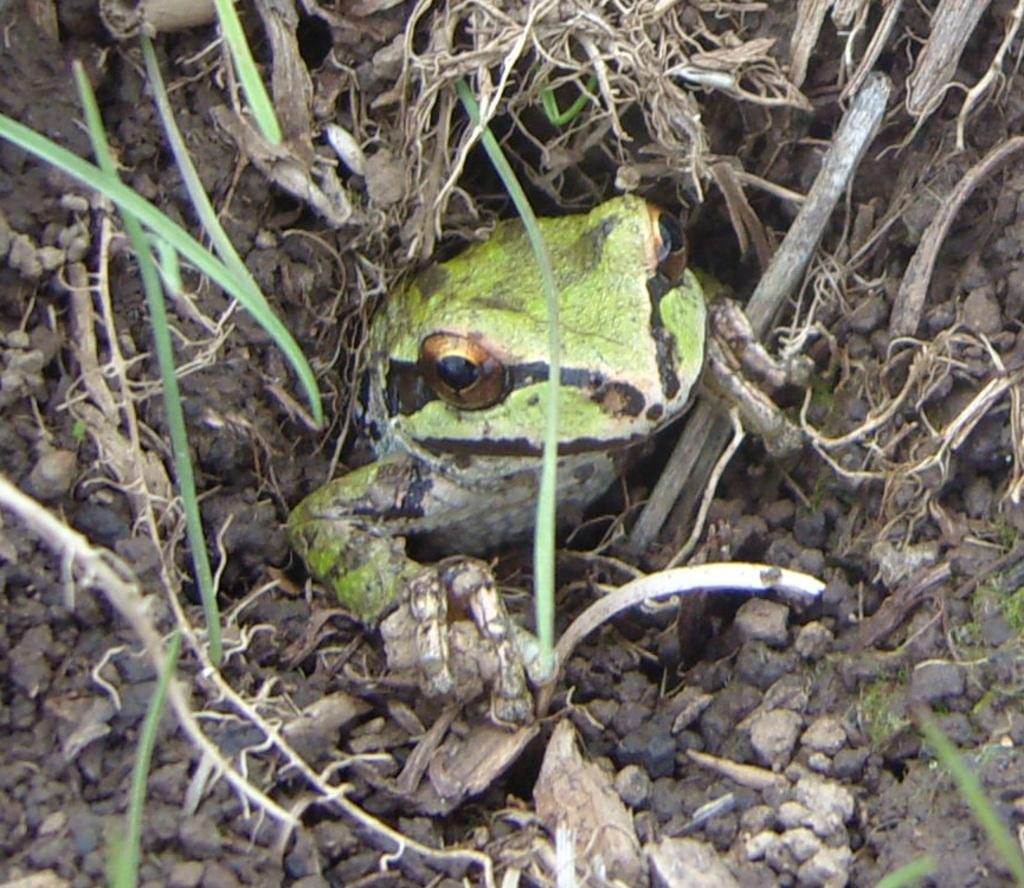What type of surface is visible in the image? There is a mud surface in the image. What feature can be seen on the mud surface? There is a hole in the mud surface. What type of vegetation is present in the image? There is grass in the image, and leaves are also present. What type of animal can be seen in the image? There is a frog in the image. What color is the frog? The frog is green in color. What type of tent can be seen in the image? There is no tent present in the image. Can you describe the spark coming from the frog in the image? There is no spark coming from the frog in the image, as frogs do not produce sparks. 